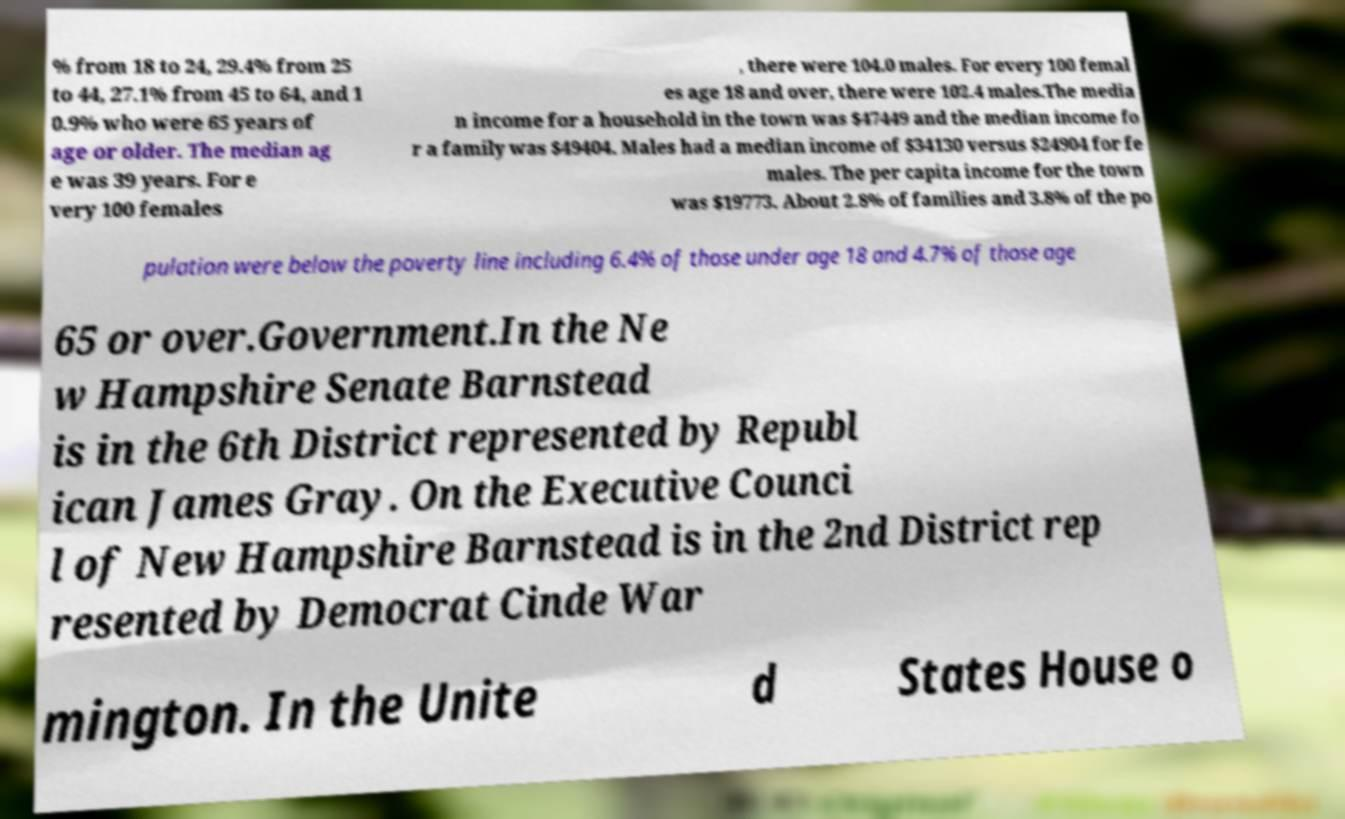Can you read and provide the text displayed in the image?This photo seems to have some interesting text. Can you extract and type it out for me? % from 18 to 24, 29.4% from 25 to 44, 27.1% from 45 to 64, and 1 0.9% who were 65 years of age or older. The median ag e was 39 years. For e very 100 females , there were 104.0 males. For every 100 femal es age 18 and over, there were 102.4 males.The media n income for a household in the town was $47449 and the median income fo r a family was $49404. Males had a median income of $34130 versus $24904 for fe males. The per capita income for the town was $19773. About 2.8% of families and 3.8% of the po pulation were below the poverty line including 6.4% of those under age 18 and 4.7% of those age 65 or over.Government.In the Ne w Hampshire Senate Barnstead is in the 6th District represented by Republ ican James Gray. On the Executive Counci l of New Hampshire Barnstead is in the 2nd District rep resented by Democrat Cinde War mington. In the Unite d States House o 